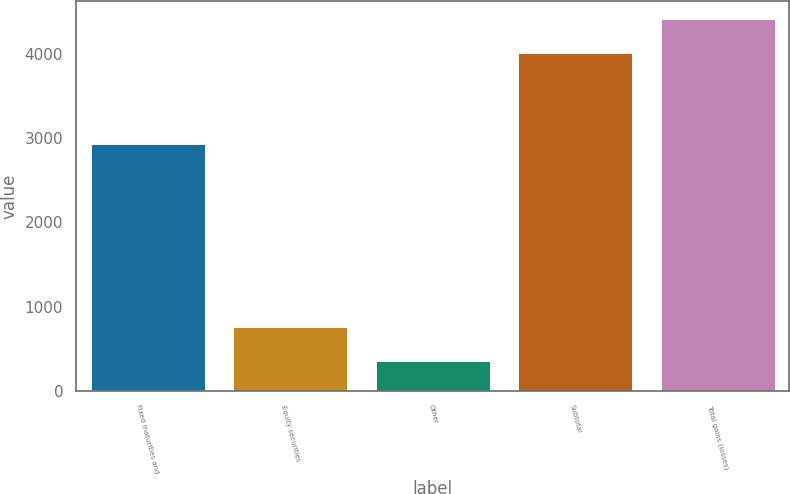Convert chart. <chart><loc_0><loc_0><loc_500><loc_500><bar_chart><fcel>Fixed maturities and<fcel>Equity securities<fcel>Other<fcel>Subtotal<fcel>Total gains (losses)<nl><fcel>2937<fcel>763.2<fcel>360<fcel>4009<fcel>4412.2<nl></chart> 